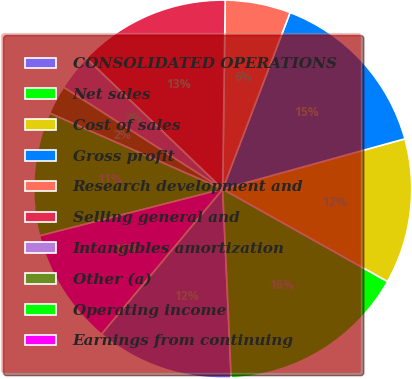Convert chart to OTSL. <chart><loc_0><loc_0><loc_500><loc_500><pie_chart><fcel>CONSOLIDATED OPERATIONS<fcel>Net sales<fcel>Cost of sales<fcel>Gross profit<fcel>Research development and<fcel>Selling general and<fcel>Intangibles amortization<fcel>Other (a)<fcel>Operating income<fcel>Earnings from continuing<nl><fcel>11.8%<fcel>16.15%<fcel>12.42%<fcel>14.91%<fcel>5.59%<fcel>13.04%<fcel>3.11%<fcel>2.48%<fcel>10.56%<fcel>9.94%<nl></chart> 